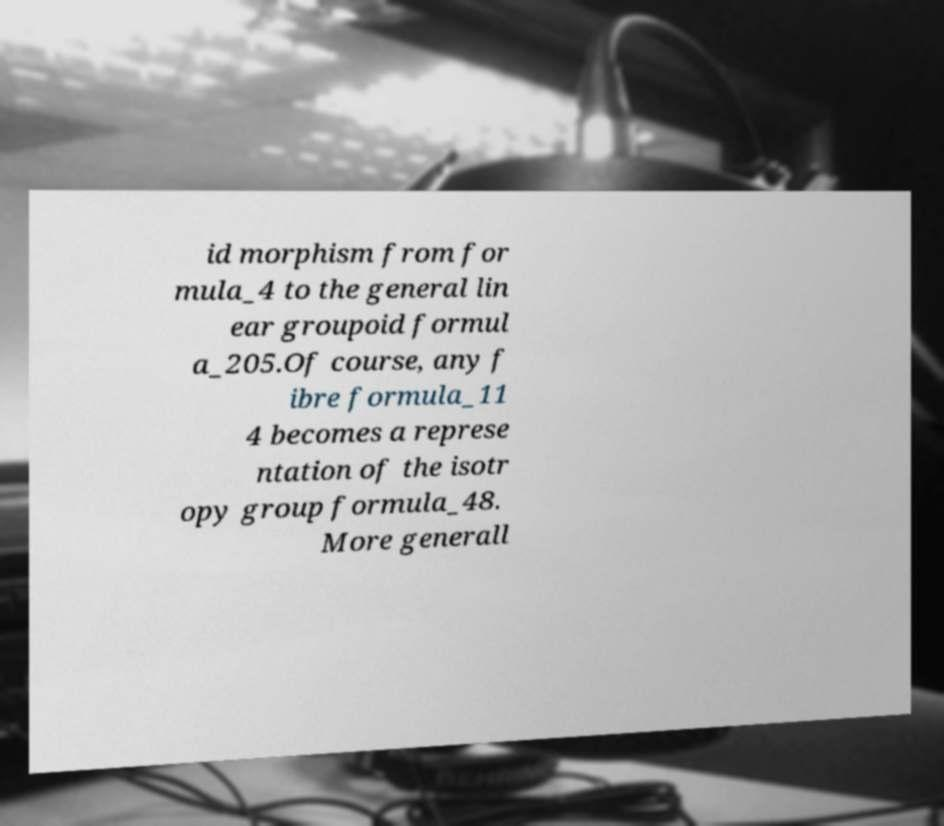For documentation purposes, I need the text within this image transcribed. Could you provide that? id morphism from for mula_4 to the general lin ear groupoid formul a_205.Of course, any f ibre formula_11 4 becomes a represe ntation of the isotr opy group formula_48. More generall 